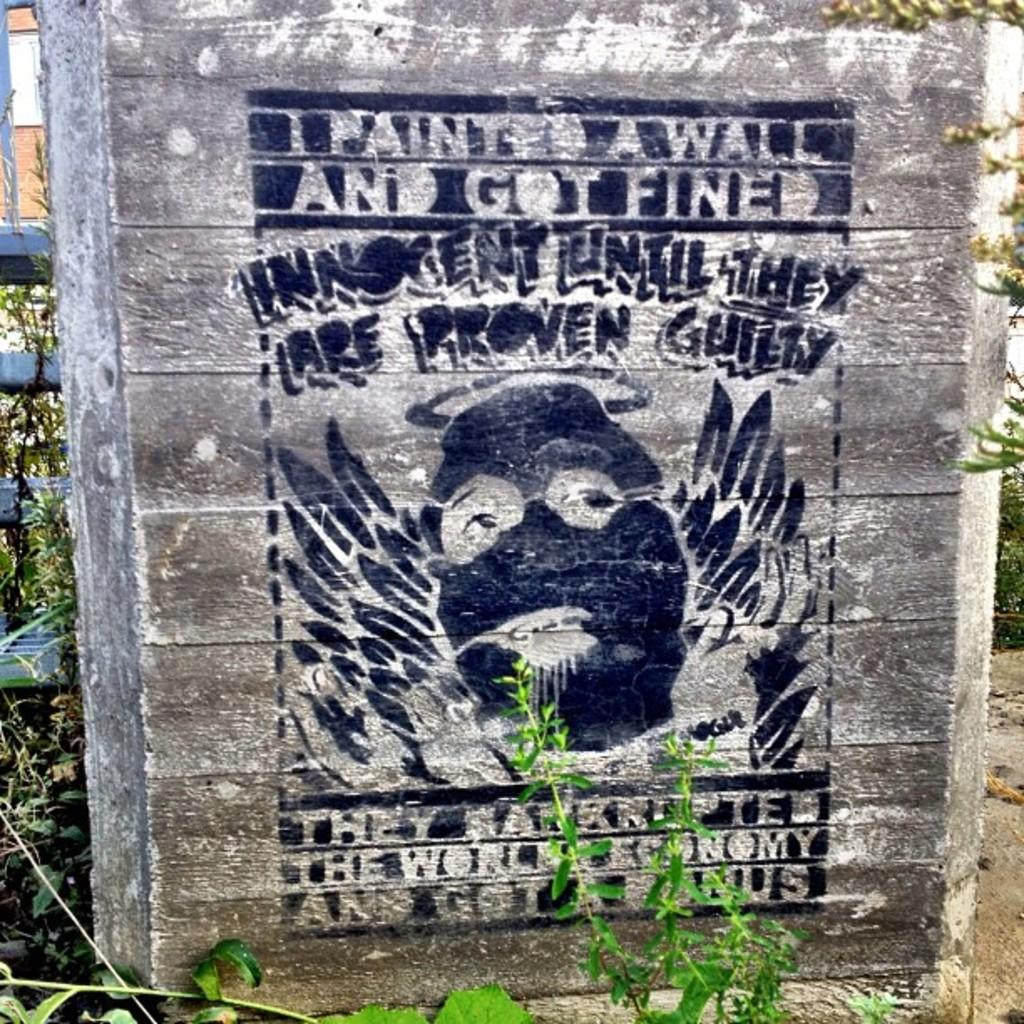What is depicted on the wooden surface in the image? There is a painting on a wooden surface in the image. What can be seen in the background of the image? There are plants and a fence in the background of the image. How many weeks has the goose been growing in the image? There is no goose present in the image, so it is not possible to determine how many weeks it has been growing. 